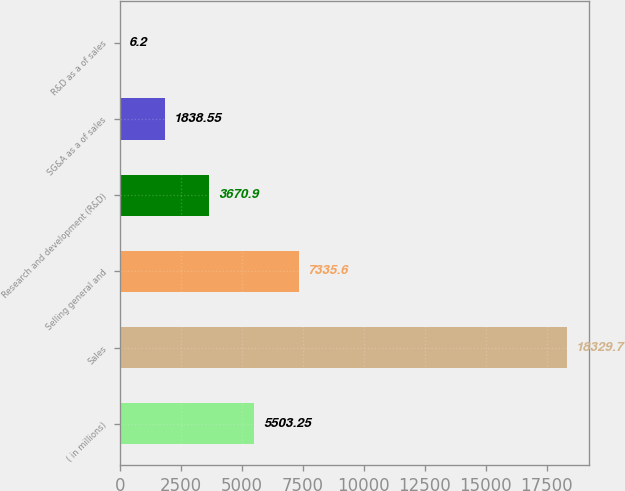<chart> <loc_0><loc_0><loc_500><loc_500><bar_chart><fcel>( in millions)<fcel>Sales<fcel>Selling general and<fcel>Research and development (R&D)<fcel>SG&A as a of sales<fcel>R&D as a of sales<nl><fcel>5503.25<fcel>18329.7<fcel>7335.6<fcel>3670.9<fcel>1838.55<fcel>6.2<nl></chart> 